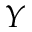Convert formula to latex. <formula><loc_0><loc_0><loc_500><loc_500>Y</formula> 